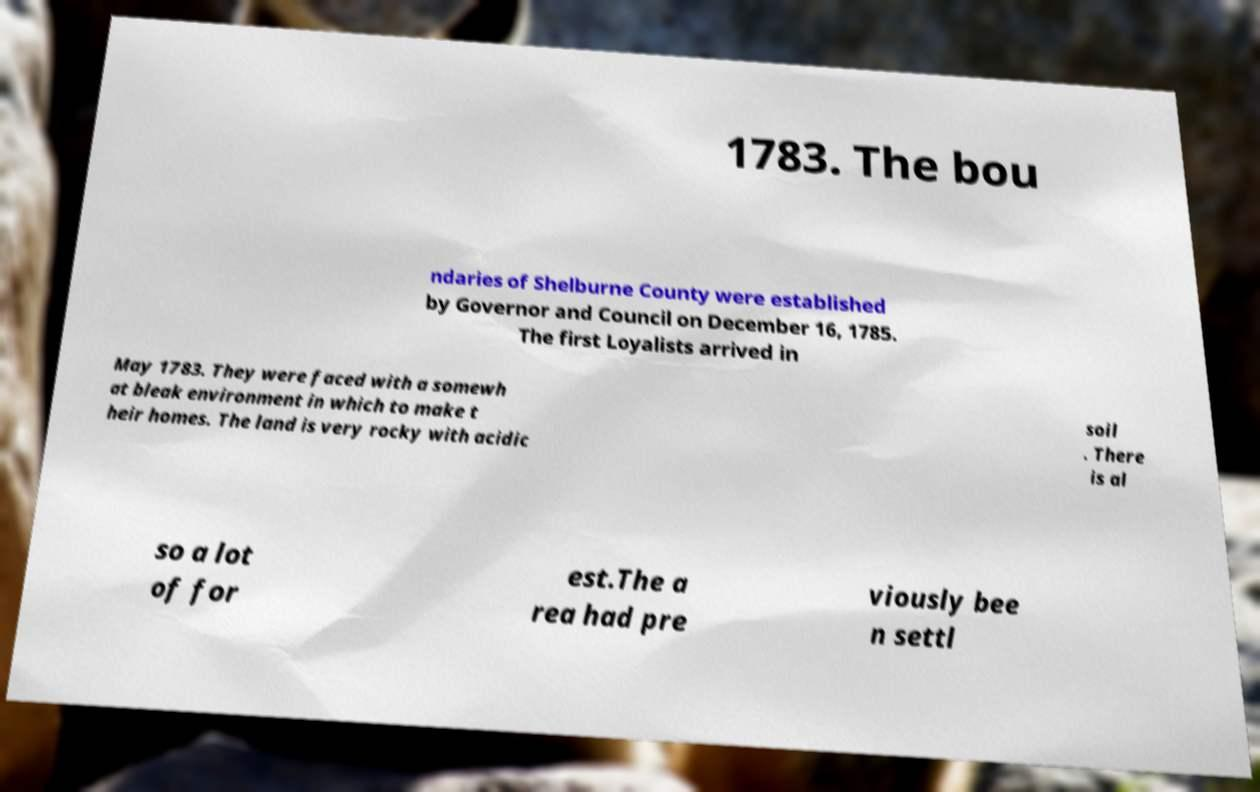Could you extract and type out the text from this image? 1783. The bou ndaries of Shelburne County were established by Governor and Council on December 16, 1785. The first Loyalists arrived in May 1783. They were faced with a somewh at bleak environment in which to make t heir homes. The land is very rocky with acidic soil . There is al so a lot of for est.The a rea had pre viously bee n settl 